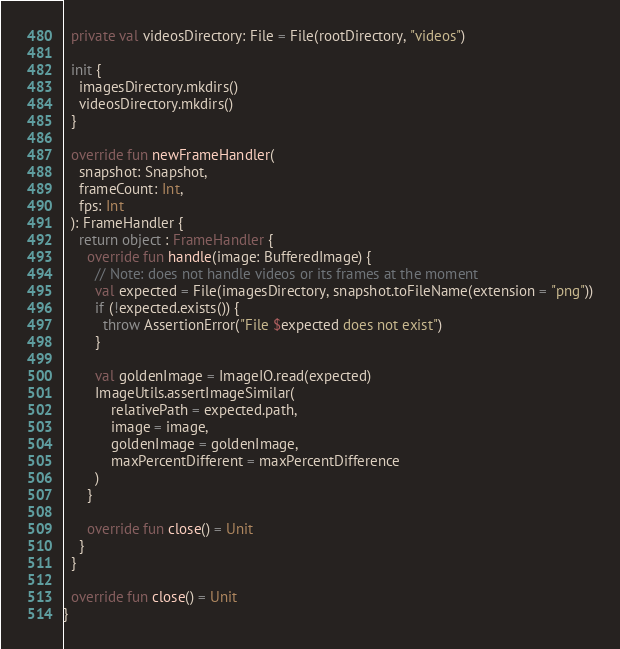<code> <loc_0><loc_0><loc_500><loc_500><_Kotlin_>  private val videosDirectory: File = File(rootDirectory, "videos")

  init {
    imagesDirectory.mkdirs()
    videosDirectory.mkdirs()
  }

  override fun newFrameHandler(
    snapshot: Snapshot,
    frameCount: Int,
    fps: Int
  ): FrameHandler {
    return object : FrameHandler {
      override fun handle(image: BufferedImage) {
        // Note: does not handle videos or its frames at the moment
        val expected = File(imagesDirectory, snapshot.toFileName(extension = "png"))
        if (!expected.exists()) {
          throw AssertionError("File $expected does not exist")
        }

        val goldenImage = ImageIO.read(expected)
        ImageUtils.assertImageSimilar(
            relativePath = expected.path,
            image = image,
            goldenImage = goldenImage,
            maxPercentDifferent = maxPercentDifference
        )
      }

      override fun close() = Unit
    }
  }

  override fun close() = Unit
}</code> 